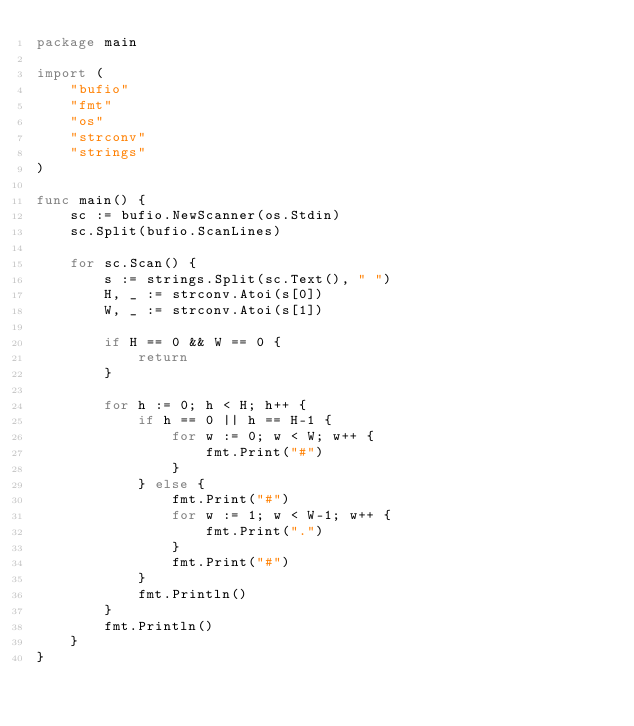<code> <loc_0><loc_0><loc_500><loc_500><_Go_>package main

import (
	"bufio"
	"fmt"
	"os"
	"strconv"
	"strings"
)

func main() {
	sc := bufio.NewScanner(os.Stdin)
	sc.Split(bufio.ScanLines)

	for sc.Scan() {
		s := strings.Split(sc.Text(), " ")
		H, _ := strconv.Atoi(s[0])
		W, _ := strconv.Atoi(s[1])

		if H == 0 && W == 0 {
			return
		}

		for h := 0; h < H; h++ {
			if h == 0 || h == H-1 {
				for w := 0; w < W; w++ {
					fmt.Print("#")
				}
			} else {
				fmt.Print("#")
				for w := 1; w < W-1; w++ {
					fmt.Print(".")
				}
				fmt.Print("#")
			}
			fmt.Println()
		}
		fmt.Println()
	}
}

</code> 